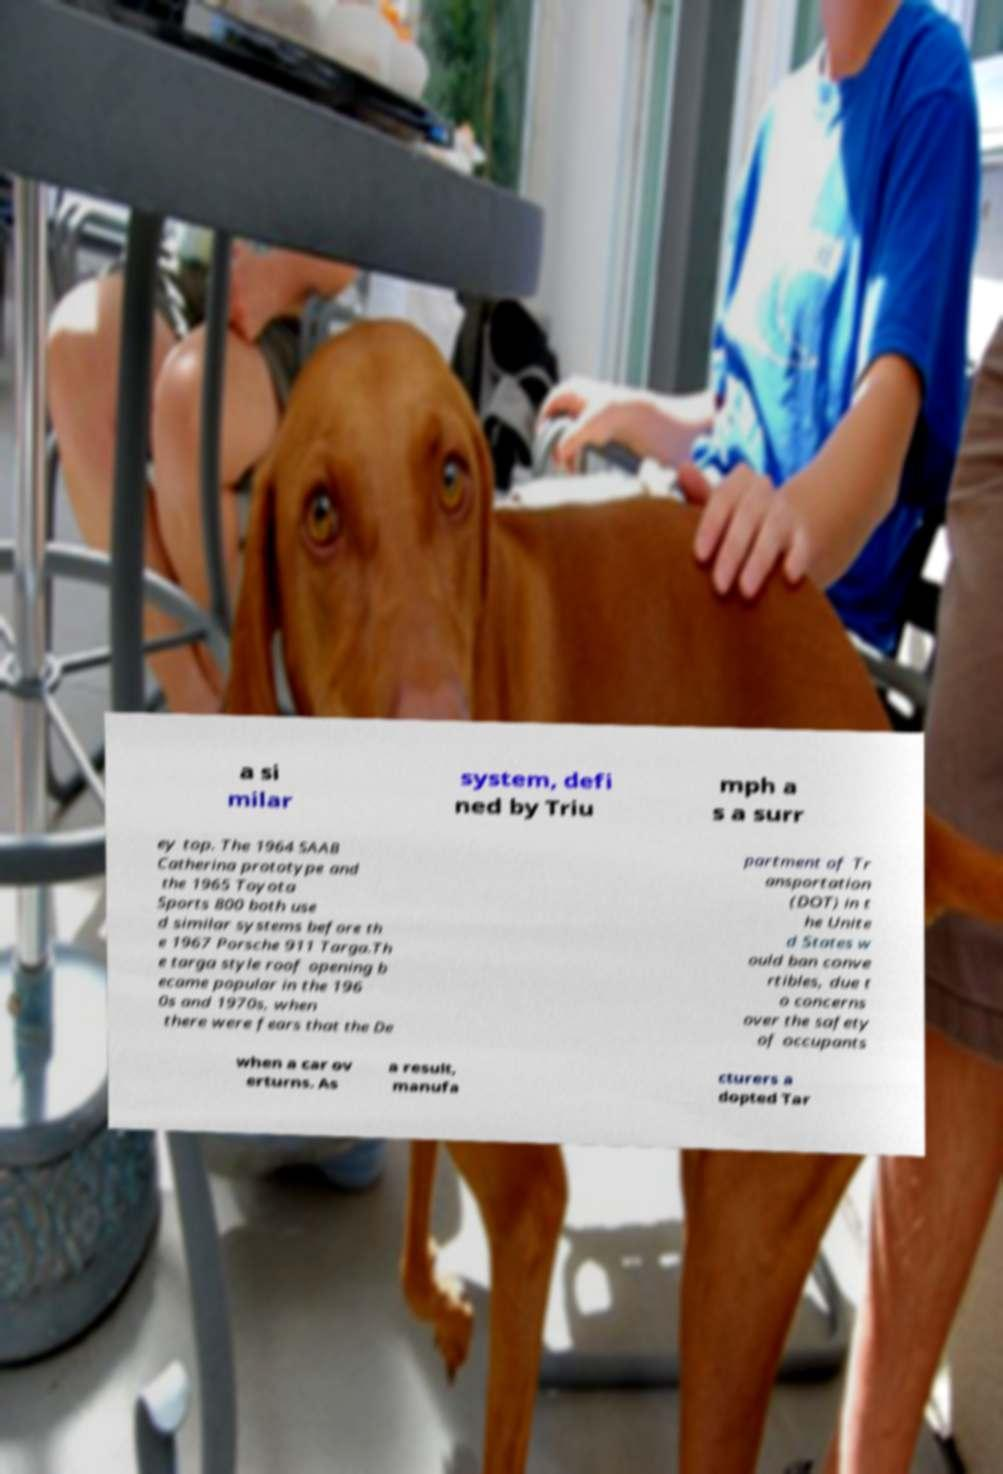Could you assist in decoding the text presented in this image and type it out clearly? a si milar system, defi ned by Triu mph a s a surr ey top. The 1964 SAAB Catherina prototype and the 1965 Toyota Sports 800 both use d similar systems before th e 1967 Porsche 911 Targa.Th e targa style roof opening b ecame popular in the 196 0s and 1970s, when there were fears that the De partment of Tr ansportation (DOT) in t he Unite d States w ould ban conve rtibles, due t o concerns over the safety of occupants when a car ov erturns. As a result, manufa cturers a dopted Tar 